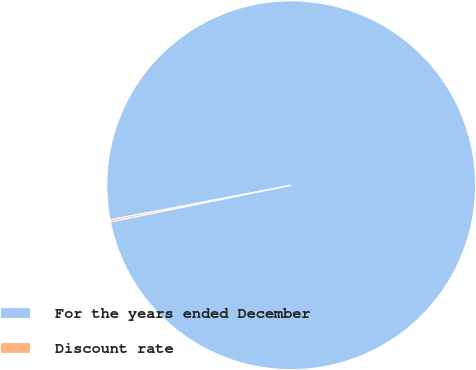Convert chart. <chart><loc_0><loc_0><loc_500><loc_500><pie_chart><fcel>For the years ended December<fcel>Discount rate<nl><fcel>99.82%<fcel>0.18%<nl></chart> 